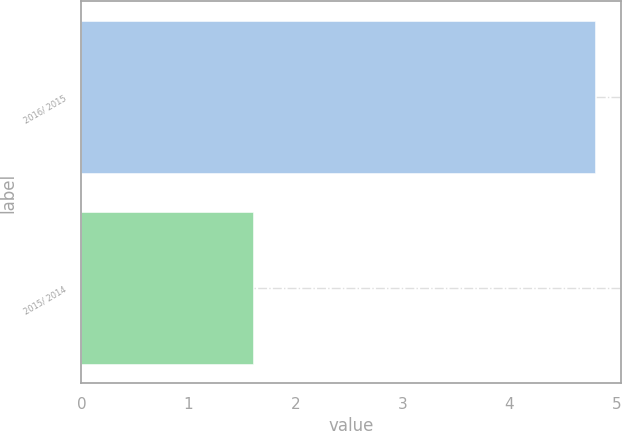Convert chart. <chart><loc_0><loc_0><loc_500><loc_500><bar_chart><fcel>2016/ 2015<fcel>2015/ 2014<nl><fcel>4.8<fcel>1.6<nl></chart> 